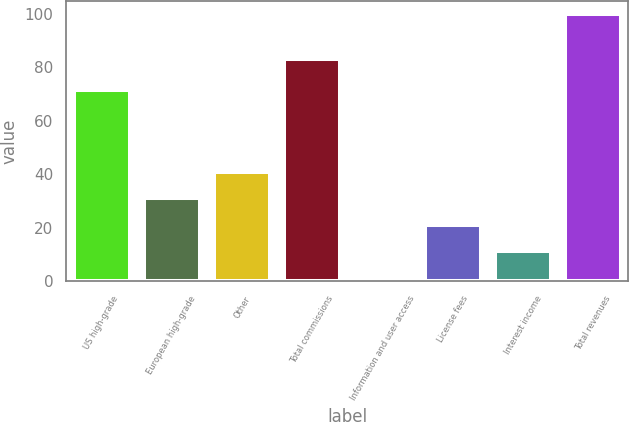<chart> <loc_0><loc_0><loc_500><loc_500><bar_chart><fcel>US high-grade<fcel>European high-grade<fcel>Other<fcel>Total commissions<fcel>Information and user access<fcel>License fees<fcel>Interest income<fcel>Total revenues<nl><fcel>71.6<fcel>31.05<fcel>40.9<fcel>83.2<fcel>1.5<fcel>21.2<fcel>11.35<fcel>100<nl></chart> 